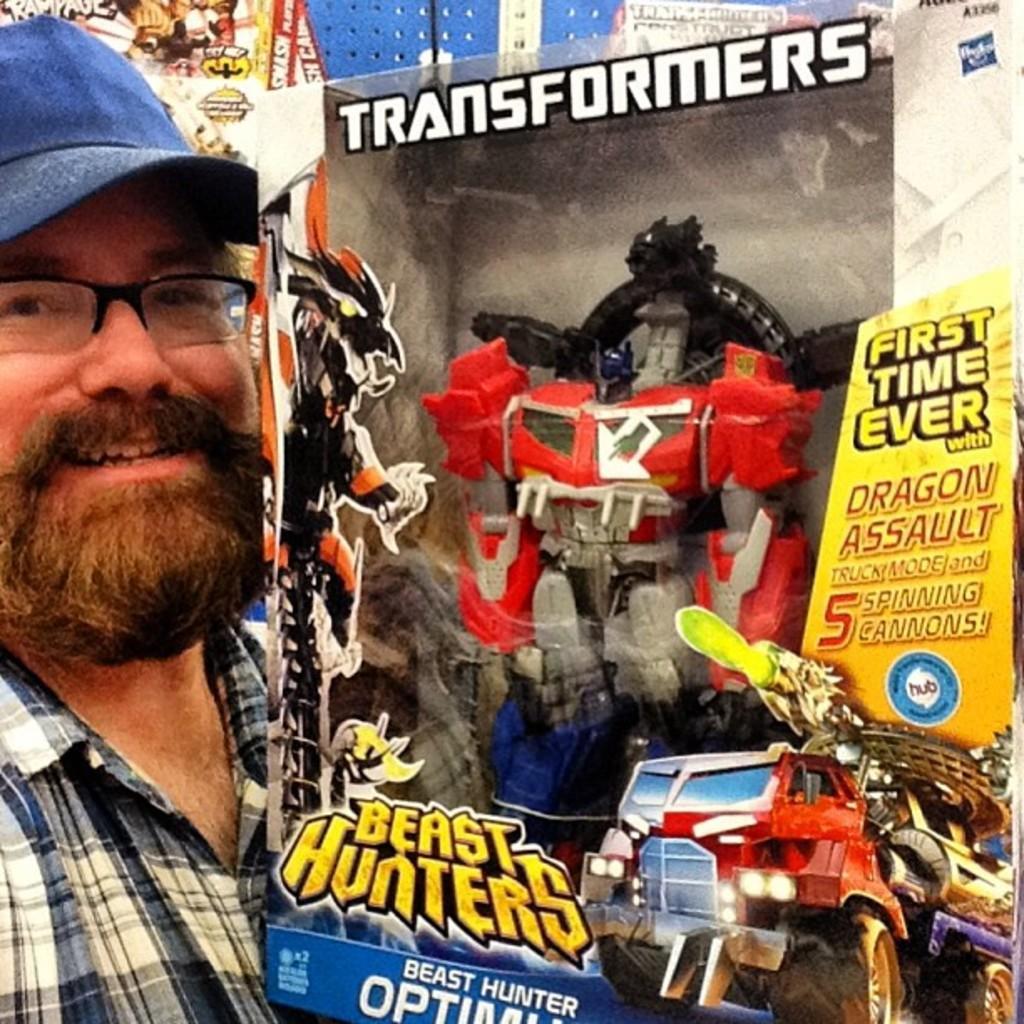Describe this image in one or two sentences. In this image I can see the person is holding the cardboard box in which I can see the toy and few stickers are attached to the box. 